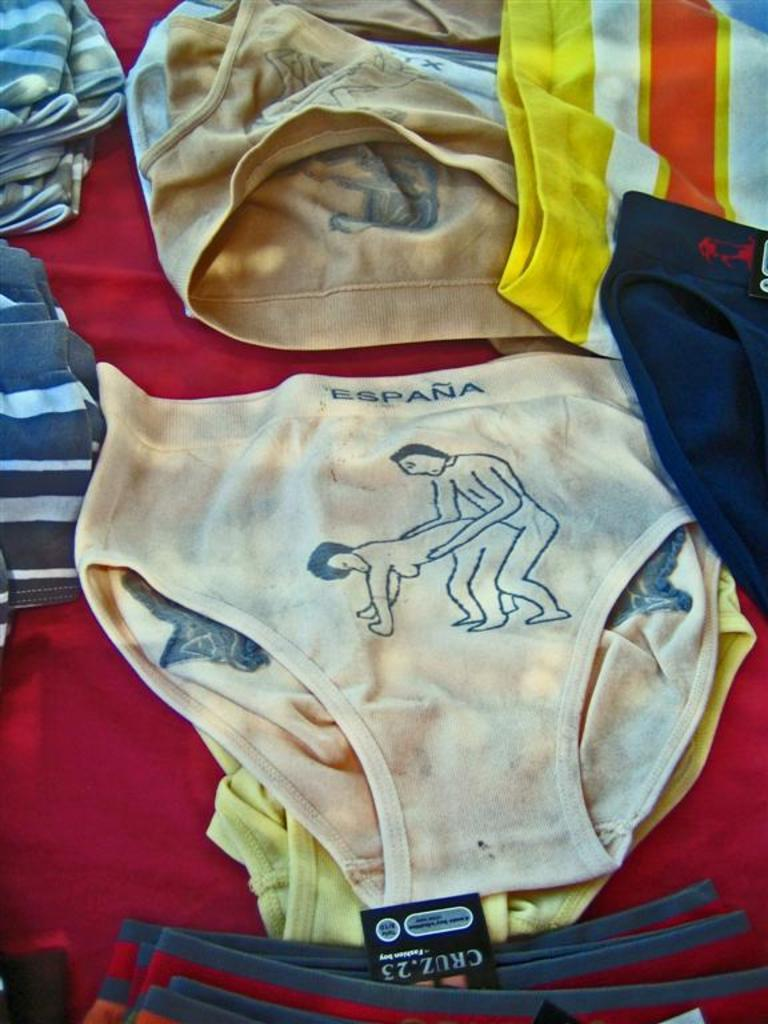<image>
Render a clear and concise summary of the photo. The country Espana is written at the top of the white underwear. 